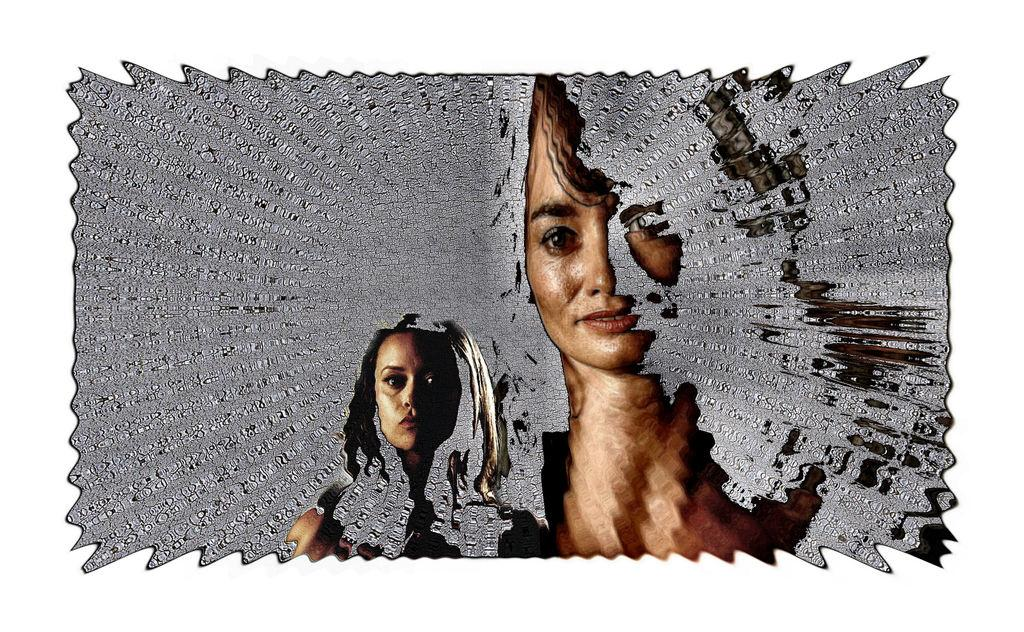How many people are in the image? There are two girls in the image. What is the position of the girls in relation to each other? The girls are beside each other. What can be observed on the girls' faces? There is blue on their faces. Are there any boats visible in the image? No, there are no boats present in the image. What type of mitten is the girl on the left wearing? There is no mitten mentioned or visible in the image. 